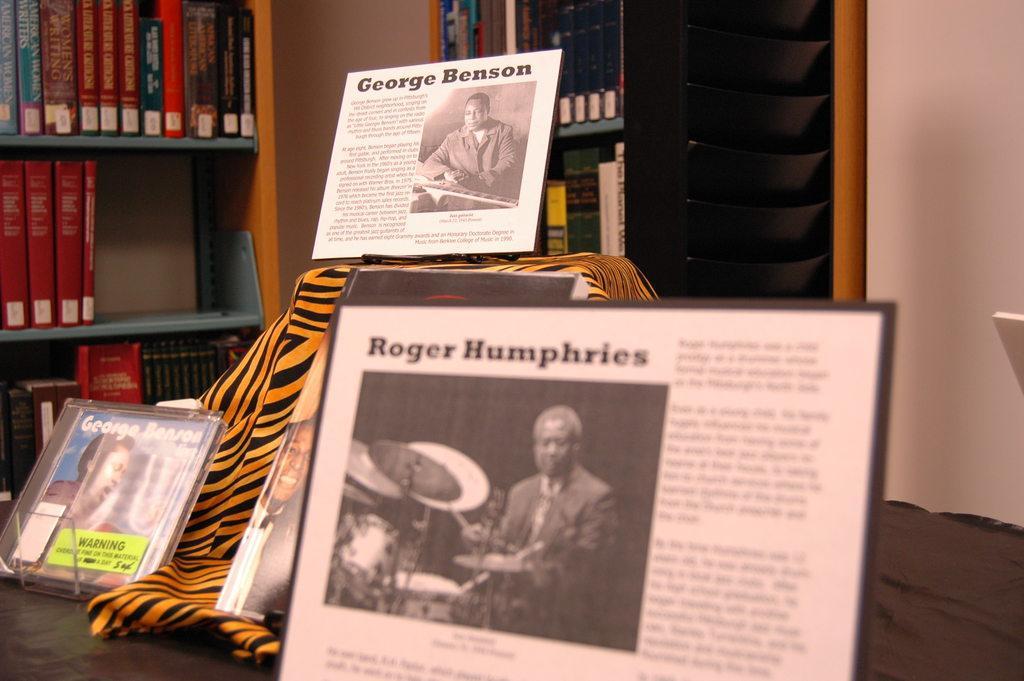Can you describe this image briefly? In this picture we can see photo frames on the platform, here we can see a cloth and in the background we can see the wall, shelves and books. 